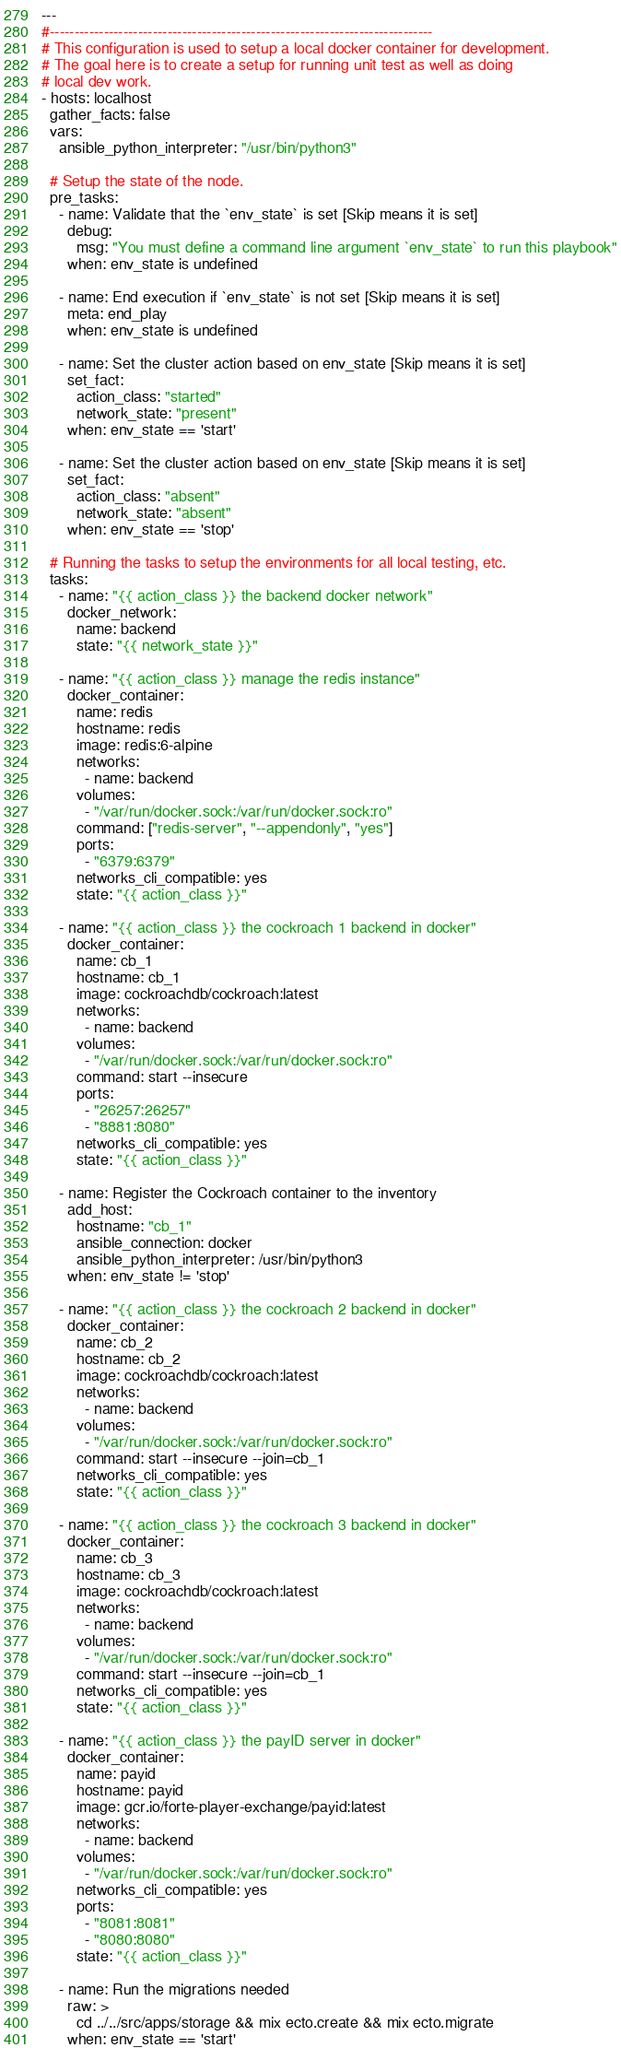Convert code to text. <code><loc_0><loc_0><loc_500><loc_500><_YAML_>---
#------------------------------------------------------------------------------
# This configuration is used to setup a local docker container for development.
# The goal here is to create a setup for running unit test as well as doing
# local dev work.
- hosts: localhost
  gather_facts: false
  vars:
    ansible_python_interpreter: "/usr/bin/python3"

  # Setup the state of the node.
  pre_tasks:
    - name: Validate that the `env_state` is set [Skip means it is set]
      debug:
        msg: "You must define a command line argument `env_state` to run this playbook"
      when: env_state is undefined

    - name: End execution if `env_state` is not set [Skip means it is set]
      meta: end_play
      when: env_state is undefined

    - name: Set the cluster action based on env_state [Skip means it is set]
      set_fact:
        action_class: "started"
        network_state: "present"
      when: env_state == 'start'

    - name: Set the cluster action based on env_state [Skip means it is set]
      set_fact:
        action_class: "absent"
        network_state: "absent"
      when: env_state == 'stop'

  # Running the tasks to setup the environments for all local testing, etc.
  tasks:
    - name: "{{ action_class }} the backend docker network"
      docker_network:
        name: backend
        state: "{{ network_state }}"

    - name: "{{ action_class }} manage the redis instance"
      docker_container:
        name: redis
        hostname: redis
        image: redis:6-alpine
        networks:
          - name: backend
        volumes:
          - "/var/run/docker.sock:/var/run/docker.sock:ro"
        command: ["redis-server", "--appendonly", "yes"]
        ports:
          - "6379:6379"
        networks_cli_compatible: yes
        state: "{{ action_class }}"

    - name: "{{ action_class }} the cockroach 1 backend in docker"
      docker_container:
        name: cb_1
        hostname: cb_1
        image: cockroachdb/cockroach:latest
        networks:
          - name: backend
        volumes:
          - "/var/run/docker.sock:/var/run/docker.sock:ro"
        command: start --insecure
        ports:
          - "26257:26257"
          - "8881:8080"
        networks_cli_compatible: yes
        state: "{{ action_class }}"

    - name: Register the Cockroach container to the inventory
      add_host:
        hostname: "cb_1"
        ansible_connection: docker
        ansible_python_interpreter: /usr/bin/python3
      when: env_state != 'stop'

    - name: "{{ action_class }} the cockroach 2 backend in docker"
      docker_container:
        name: cb_2
        hostname: cb_2
        image: cockroachdb/cockroach:latest
        networks:
          - name: backend
        volumes:
          - "/var/run/docker.sock:/var/run/docker.sock:ro"
        command: start --insecure --join=cb_1
        networks_cli_compatible: yes
        state: "{{ action_class }}"

    - name: "{{ action_class }} the cockroach 3 backend in docker"
      docker_container:
        name: cb_3
        hostname: cb_3
        image: cockroachdb/cockroach:latest
        networks:
          - name: backend
        volumes:
          - "/var/run/docker.sock:/var/run/docker.sock:ro"
        command: start --insecure --join=cb_1
        networks_cli_compatible: yes
        state: "{{ action_class }}"

    - name: "{{ action_class }} the payID server in docker"
      docker_container:
        name: payid
        hostname: payid
        image: gcr.io/forte-player-exchange/payid:latest
        networks:
          - name: backend
        volumes:
          - "/var/run/docker.sock:/var/run/docker.sock:ro"
        networks_cli_compatible: yes
        ports:
          - "8081:8081"
          - "8080:8080"
        state: "{{ action_class }}"

    - name: Run the migrations needed
      raw: >
        cd ../../src/apps/storage && mix ecto.create && mix ecto.migrate
      when: env_state == 'start'
</code> 